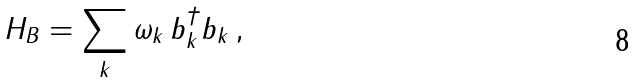Convert formula to latex. <formula><loc_0><loc_0><loc_500><loc_500>H _ { B } = \sum _ { k } \omega _ { k } \, b _ { k } ^ { \dag } b _ { k } \, ,</formula> 